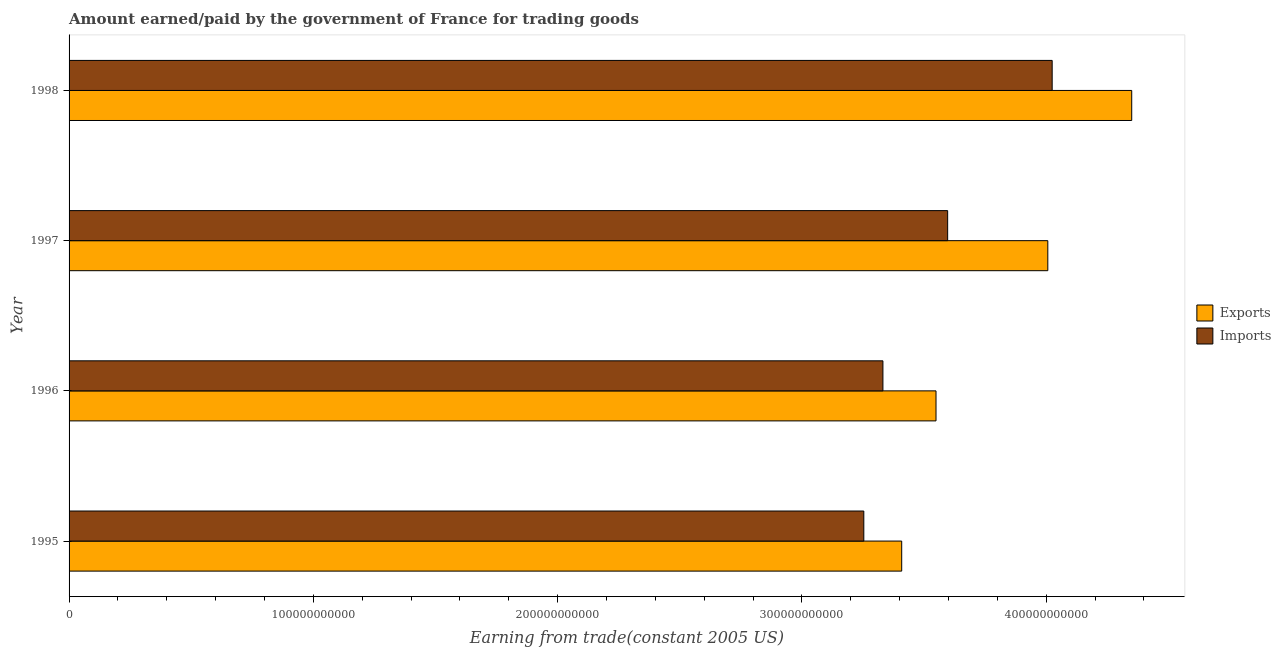Are the number of bars per tick equal to the number of legend labels?
Provide a short and direct response. Yes. How many bars are there on the 1st tick from the top?
Offer a terse response. 2. In how many cases, is the number of bars for a given year not equal to the number of legend labels?
Give a very brief answer. 0. What is the amount earned from exports in 1998?
Offer a very short reply. 4.35e+11. Across all years, what is the maximum amount paid for imports?
Offer a terse response. 4.02e+11. Across all years, what is the minimum amount earned from exports?
Ensure brevity in your answer.  3.41e+11. In which year was the amount paid for imports maximum?
Give a very brief answer. 1998. What is the total amount paid for imports in the graph?
Offer a terse response. 1.42e+12. What is the difference between the amount earned from exports in 1996 and that in 1998?
Keep it short and to the point. -8.01e+1. What is the difference between the amount earned from exports in 1995 and the amount paid for imports in 1997?
Give a very brief answer. -1.88e+1. What is the average amount earned from exports per year?
Your answer should be compact. 3.83e+11. In the year 1995, what is the difference between the amount earned from exports and amount paid for imports?
Provide a succinct answer. 1.55e+1. In how many years, is the amount earned from exports greater than 360000000000 US$?
Provide a short and direct response. 2. What is the ratio of the amount paid for imports in 1995 to that in 1998?
Make the answer very short. 0.81. What is the difference between the highest and the second highest amount paid for imports?
Provide a succinct answer. 4.28e+1. What is the difference between the highest and the lowest amount earned from exports?
Provide a short and direct response. 9.42e+1. In how many years, is the amount earned from exports greater than the average amount earned from exports taken over all years?
Your answer should be compact. 2. What does the 1st bar from the top in 1997 represents?
Provide a short and direct response. Imports. What does the 2nd bar from the bottom in 1997 represents?
Provide a short and direct response. Imports. How many bars are there?
Your answer should be compact. 8. What is the difference between two consecutive major ticks on the X-axis?
Make the answer very short. 1.00e+11. Does the graph contain grids?
Provide a succinct answer. No. Where does the legend appear in the graph?
Offer a very short reply. Center right. What is the title of the graph?
Offer a terse response. Amount earned/paid by the government of France for trading goods. What is the label or title of the X-axis?
Offer a terse response. Earning from trade(constant 2005 US). What is the Earning from trade(constant 2005 US) of Exports in 1995?
Offer a terse response. 3.41e+11. What is the Earning from trade(constant 2005 US) of Imports in 1995?
Provide a succinct answer. 3.25e+11. What is the Earning from trade(constant 2005 US) in Exports in 1996?
Offer a very short reply. 3.55e+11. What is the Earning from trade(constant 2005 US) in Imports in 1996?
Make the answer very short. 3.33e+11. What is the Earning from trade(constant 2005 US) in Exports in 1997?
Offer a very short reply. 4.01e+11. What is the Earning from trade(constant 2005 US) in Imports in 1997?
Offer a terse response. 3.60e+11. What is the Earning from trade(constant 2005 US) of Exports in 1998?
Ensure brevity in your answer.  4.35e+11. What is the Earning from trade(constant 2005 US) of Imports in 1998?
Give a very brief answer. 4.02e+11. Across all years, what is the maximum Earning from trade(constant 2005 US) of Exports?
Your answer should be very brief. 4.35e+11. Across all years, what is the maximum Earning from trade(constant 2005 US) in Imports?
Keep it short and to the point. 4.02e+11. Across all years, what is the minimum Earning from trade(constant 2005 US) of Exports?
Offer a very short reply. 3.41e+11. Across all years, what is the minimum Earning from trade(constant 2005 US) of Imports?
Make the answer very short. 3.25e+11. What is the total Earning from trade(constant 2005 US) in Exports in the graph?
Offer a terse response. 1.53e+12. What is the total Earning from trade(constant 2005 US) in Imports in the graph?
Your answer should be compact. 1.42e+12. What is the difference between the Earning from trade(constant 2005 US) in Exports in 1995 and that in 1996?
Provide a succinct answer. -1.40e+1. What is the difference between the Earning from trade(constant 2005 US) in Imports in 1995 and that in 1996?
Keep it short and to the point. -7.82e+09. What is the difference between the Earning from trade(constant 2005 US) of Exports in 1995 and that in 1997?
Your answer should be very brief. -5.98e+1. What is the difference between the Earning from trade(constant 2005 US) in Imports in 1995 and that in 1997?
Your answer should be very brief. -3.43e+1. What is the difference between the Earning from trade(constant 2005 US) in Exports in 1995 and that in 1998?
Give a very brief answer. -9.42e+1. What is the difference between the Earning from trade(constant 2005 US) of Imports in 1995 and that in 1998?
Give a very brief answer. -7.71e+1. What is the difference between the Earning from trade(constant 2005 US) in Exports in 1996 and that in 1997?
Your answer should be compact. -4.58e+1. What is the difference between the Earning from trade(constant 2005 US) in Imports in 1996 and that in 1997?
Offer a terse response. -2.65e+1. What is the difference between the Earning from trade(constant 2005 US) of Exports in 1996 and that in 1998?
Ensure brevity in your answer.  -8.01e+1. What is the difference between the Earning from trade(constant 2005 US) in Imports in 1996 and that in 1998?
Your response must be concise. -6.93e+1. What is the difference between the Earning from trade(constant 2005 US) in Exports in 1997 and that in 1998?
Your answer should be compact. -3.43e+1. What is the difference between the Earning from trade(constant 2005 US) of Imports in 1997 and that in 1998?
Make the answer very short. -4.28e+1. What is the difference between the Earning from trade(constant 2005 US) of Exports in 1995 and the Earning from trade(constant 2005 US) of Imports in 1996?
Give a very brief answer. 7.69e+09. What is the difference between the Earning from trade(constant 2005 US) in Exports in 1995 and the Earning from trade(constant 2005 US) in Imports in 1997?
Ensure brevity in your answer.  -1.88e+1. What is the difference between the Earning from trade(constant 2005 US) in Exports in 1995 and the Earning from trade(constant 2005 US) in Imports in 1998?
Keep it short and to the point. -6.16e+1. What is the difference between the Earning from trade(constant 2005 US) of Exports in 1996 and the Earning from trade(constant 2005 US) of Imports in 1997?
Give a very brief answer. -4.76e+09. What is the difference between the Earning from trade(constant 2005 US) of Exports in 1996 and the Earning from trade(constant 2005 US) of Imports in 1998?
Make the answer very short. -4.76e+1. What is the difference between the Earning from trade(constant 2005 US) of Exports in 1997 and the Earning from trade(constant 2005 US) of Imports in 1998?
Give a very brief answer. -1.79e+09. What is the average Earning from trade(constant 2005 US) of Exports per year?
Your answer should be very brief. 3.83e+11. What is the average Earning from trade(constant 2005 US) of Imports per year?
Provide a short and direct response. 3.55e+11. In the year 1995, what is the difference between the Earning from trade(constant 2005 US) of Exports and Earning from trade(constant 2005 US) of Imports?
Make the answer very short. 1.55e+1. In the year 1996, what is the difference between the Earning from trade(constant 2005 US) in Exports and Earning from trade(constant 2005 US) in Imports?
Make the answer very short. 2.17e+1. In the year 1997, what is the difference between the Earning from trade(constant 2005 US) in Exports and Earning from trade(constant 2005 US) in Imports?
Provide a short and direct response. 4.10e+1. In the year 1998, what is the difference between the Earning from trade(constant 2005 US) of Exports and Earning from trade(constant 2005 US) of Imports?
Offer a terse response. 3.26e+1. What is the ratio of the Earning from trade(constant 2005 US) in Exports in 1995 to that in 1996?
Offer a terse response. 0.96. What is the ratio of the Earning from trade(constant 2005 US) of Imports in 1995 to that in 1996?
Offer a very short reply. 0.98. What is the ratio of the Earning from trade(constant 2005 US) of Exports in 1995 to that in 1997?
Provide a short and direct response. 0.85. What is the ratio of the Earning from trade(constant 2005 US) of Imports in 1995 to that in 1997?
Keep it short and to the point. 0.9. What is the ratio of the Earning from trade(constant 2005 US) of Exports in 1995 to that in 1998?
Offer a terse response. 0.78. What is the ratio of the Earning from trade(constant 2005 US) of Imports in 1995 to that in 1998?
Make the answer very short. 0.81. What is the ratio of the Earning from trade(constant 2005 US) of Exports in 1996 to that in 1997?
Give a very brief answer. 0.89. What is the ratio of the Earning from trade(constant 2005 US) of Imports in 1996 to that in 1997?
Offer a terse response. 0.93. What is the ratio of the Earning from trade(constant 2005 US) of Exports in 1996 to that in 1998?
Your response must be concise. 0.82. What is the ratio of the Earning from trade(constant 2005 US) in Imports in 1996 to that in 1998?
Keep it short and to the point. 0.83. What is the ratio of the Earning from trade(constant 2005 US) in Exports in 1997 to that in 1998?
Provide a short and direct response. 0.92. What is the ratio of the Earning from trade(constant 2005 US) of Imports in 1997 to that in 1998?
Your answer should be compact. 0.89. What is the difference between the highest and the second highest Earning from trade(constant 2005 US) of Exports?
Your answer should be very brief. 3.43e+1. What is the difference between the highest and the second highest Earning from trade(constant 2005 US) in Imports?
Make the answer very short. 4.28e+1. What is the difference between the highest and the lowest Earning from trade(constant 2005 US) in Exports?
Keep it short and to the point. 9.42e+1. What is the difference between the highest and the lowest Earning from trade(constant 2005 US) in Imports?
Provide a succinct answer. 7.71e+1. 